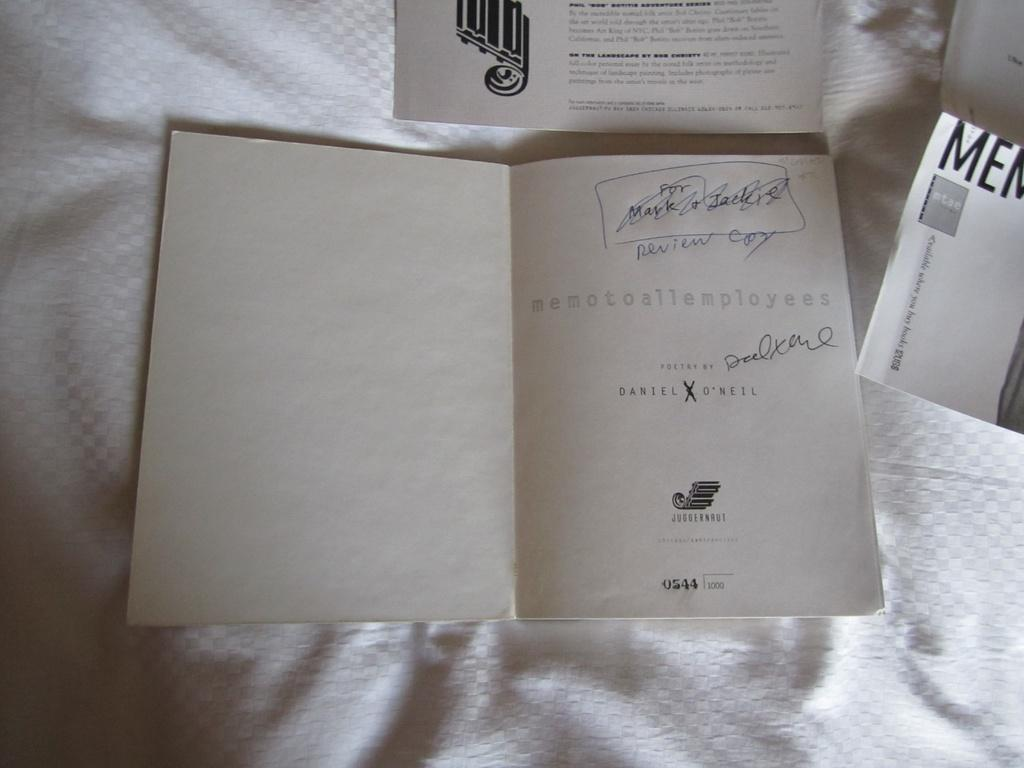<image>
Share a concise interpretation of the image provided. A library book bears the publisher name Juggernaut on it. 